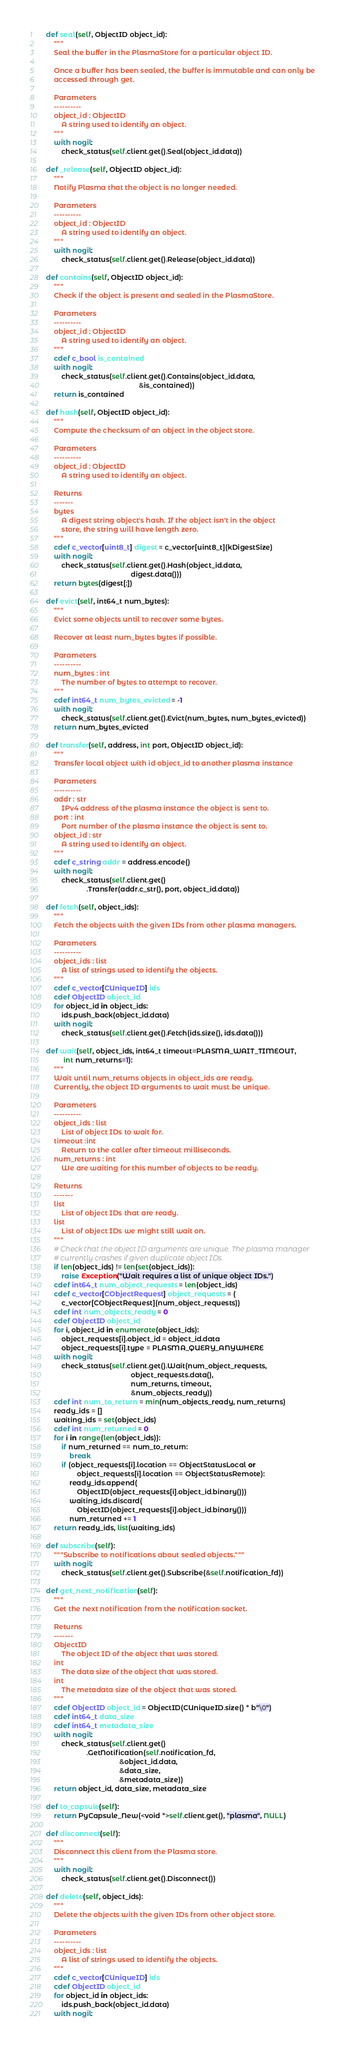Convert code to text. <code><loc_0><loc_0><loc_500><loc_500><_Cython_>
    def seal(self, ObjectID object_id):
        """
        Seal the buffer in the PlasmaStore for a particular object ID.

        Once a buffer has been sealed, the buffer is immutable and can only be
        accessed through get.

        Parameters
        ----------
        object_id : ObjectID
            A string used to identify an object.
        """
        with nogil:
            check_status(self.client.get().Seal(object_id.data))

    def _release(self, ObjectID object_id):
        """
        Notify Plasma that the object is no longer needed.

        Parameters
        ----------
        object_id : ObjectID
            A string used to identify an object.
        """
        with nogil:
            check_status(self.client.get().Release(object_id.data))

    def contains(self, ObjectID object_id):
        """
        Check if the object is present and sealed in the PlasmaStore.

        Parameters
        ----------
        object_id : ObjectID
            A string used to identify an object.
        """
        cdef c_bool is_contained
        with nogil:
            check_status(self.client.get().Contains(object_id.data,
                                                    &is_contained))
        return is_contained

    def hash(self, ObjectID object_id):
        """
        Compute the checksum of an object in the object store.

        Parameters
        ----------
        object_id : ObjectID
            A string used to identify an object.

        Returns
        -------
        bytes
            A digest string object's hash. If the object isn't in the object
            store, the string will have length zero.
        """
        cdef c_vector[uint8_t] digest = c_vector[uint8_t](kDigestSize)
        with nogil:
            check_status(self.client.get().Hash(object_id.data,
                                                digest.data()))
        return bytes(digest[:])

    def evict(self, int64_t num_bytes):
        """
        Evict some objects until to recover some bytes.

        Recover at least num_bytes bytes if possible.

        Parameters
        ----------
        num_bytes : int
            The number of bytes to attempt to recover.
        """
        cdef int64_t num_bytes_evicted = -1
        with nogil:
            check_status(self.client.get().Evict(num_bytes, num_bytes_evicted))
        return num_bytes_evicted

    def transfer(self, address, int port, ObjectID object_id):
        """
        Transfer local object with id object_id to another plasma instance

        Parameters
        ----------
        addr : str
            IPv4 address of the plasma instance the object is sent to.
        port : int
            Port number of the plasma instance the object is sent to.
        object_id : str
            A string used to identify an object.
        """
        cdef c_string addr = address.encode()
        with nogil:
            check_status(self.client.get()
                         .Transfer(addr.c_str(), port, object_id.data))

    def fetch(self, object_ids):
        """
        Fetch the objects with the given IDs from other plasma managers.

        Parameters
        ----------
        object_ids : list
            A list of strings used to identify the objects.
        """
        cdef c_vector[CUniqueID] ids
        cdef ObjectID object_id
        for object_id in object_ids:
            ids.push_back(object_id.data)
        with nogil:
            check_status(self.client.get().Fetch(ids.size(), ids.data()))

    def wait(self, object_ids, int64_t timeout=PLASMA_WAIT_TIMEOUT,
             int num_returns=1):
        """
        Wait until num_returns objects in object_ids are ready.
        Currently, the object ID arguments to wait must be unique.

        Parameters
        ----------
        object_ids : list
            List of object IDs to wait for.
        timeout :int
            Return to the caller after timeout milliseconds.
        num_returns : int
            We are waiting for this number of objects to be ready.

        Returns
        -------
        list
            List of object IDs that are ready.
        list
            List of object IDs we might still wait on.
        """
        # Check that the object ID arguments are unique. The plasma manager
        # currently crashes if given duplicate object IDs.
        if len(object_ids) != len(set(object_ids)):
            raise Exception("Wait requires a list of unique object IDs.")
        cdef int64_t num_object_requests = len(object_ids)
        cdef c_vector[CObjectRequest] object_requests = (
            c_vector[CObjectRequest](num_object_requests))
        cdef int num_objects_ready = 0
        cdef ObjectID object_id
        for i, object_id in enumerate(object_ids):
            object_requests[i].object_id = object_id.data
            object_requests[i].type = PLASMA_QUERY_ANYWHERE
        with nogil:
            check_status(self.client.get().Wait(num_object_requests,
                                                object_requests.data(),
                                                num_returns, timeout,
                                                &num_objects_ready))
        cdef int num_to_return = min(num_objects_ready, num_returns)
        ready_ids = []
        waiting_ids = set(object_ids)
        cdef int num_returned = 0
        for i in range(len(object_ids)):
            if num_returned == num_to_return:
                break
            if (object_requests[i].location == ObjectStatusLocal or
                    object_requests[i].location == ObjectStatusRemote):
                ready_ids.append(
                    ObjectID(object_requests[i].object_id.binary()))
                waiting_ids.discard(
                    ObjectID(object_requests[i].object_id.binary()))
                num_returned += 1
        return ready_ids, list(waiting_ids)

    def subscribe(self):
        """Subscribe to notifications about sealed objects."""
        with nogil:
            check_status(self.client.get().Subscribe(&self.notification_fd))

    def get_next_notification(self):
        """
        Get the next notification from the notification socket.

        Returns
        -------
        ObjectID
            The object ID of the object that was stored.
        int
            The data size of the object that was stored.
        int
            The metadata size of the object that was stored.
        """
        cdef ObjectID object_id = ObjectID(CUniqueID.size() * b"\0")
        cdef int64_t data_size
        cdef int64_t metadata_size
        with nogil:
            check_status(self.client.get()
                         .GetNotification(self.notification_fd,
                                          &object_id.data,
                                          &data_size,
                                          &metadata_size))
        return object_id, data_size, metadata_size

    def to_capsule(self):
        return PyCapsule_New(<void *>self.client.get(), "plasma", NULL)

    def disconnect(self):
        """
        Disconnect this client from the Plasma store.
        """
        with nogil:
            check_status(self.client.get().Disconnect())

    def delete(self, object_ids):
        """
        Delete the objects with the given IDs from other object store.

        Parameters
        ----------
        object_ids : list
            A list of strings used to identify the objects.
        """
        cdef c_vector[CUniqueID] ids
        cdef ObjectID object_id
        for object_id in object_ids:
            ids.push_back(object_id.data)
        with nogil:</code> 